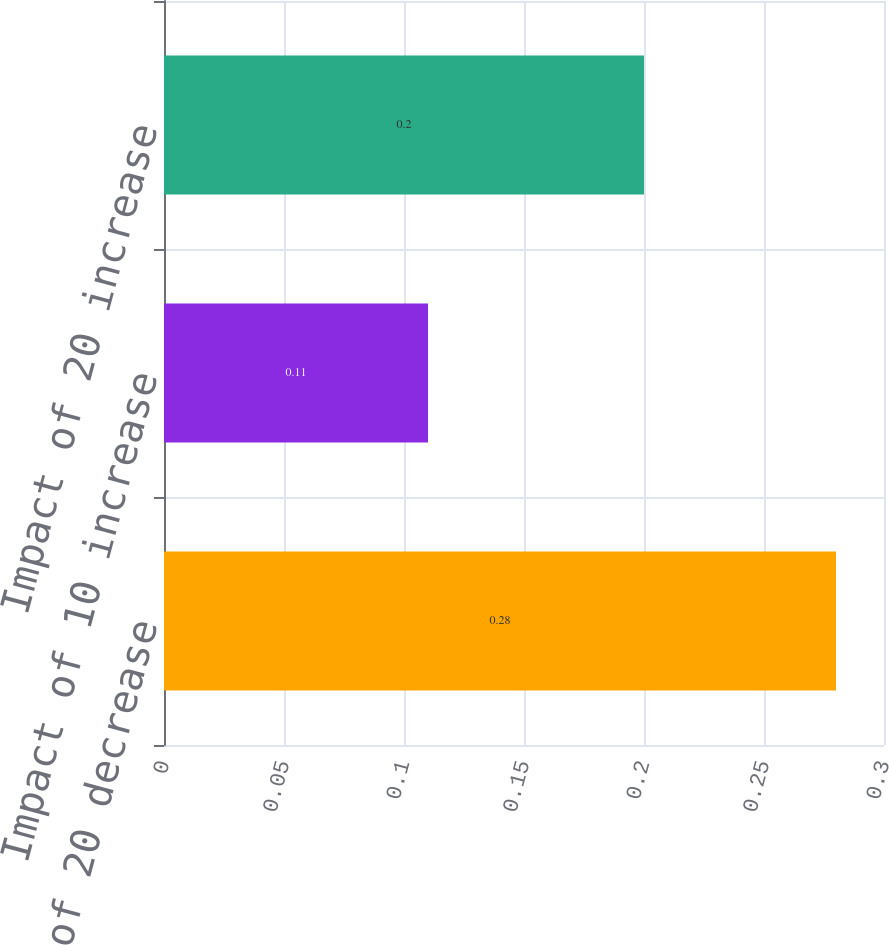Convert chart to OTSL. <chart><loc_0><loc_0><loc_500><loc_500><bar_chart><fcel>Impact of 20 decrease<fcel>Impact of 10 increase<fcel>Impact of 20 increase<nl><fcel>0.28<fcel>0.11<fcel>0.2<nl></chart> 